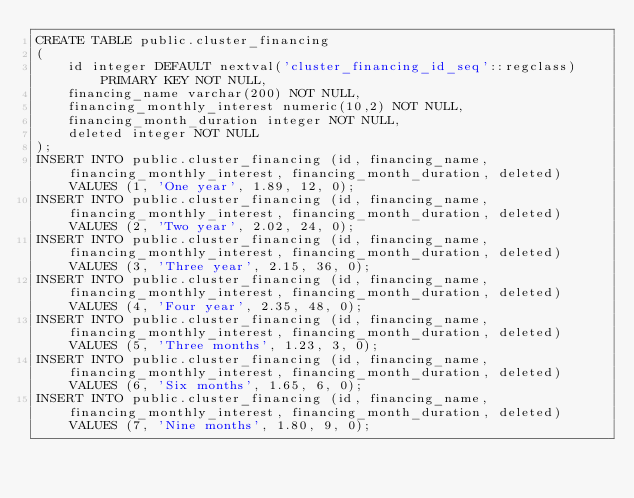<code> <loc_0><loc_0><loc_500><loc_500><_SQL_>CREATE TABLE public.cluster_financing
(
    id integer DEFAULT nextval('cluster_financing_id_seq'::regclass) PRIMARY KEY NOT NULL,
    financing_name varchar(200) NOT NULL,
    financing_monthly_interest numeric(10,2) NOT NULL,
    financing_month_duration integer NOT NULL,
    deleted integer NOT NULL
);
INSERT INTO public.cluster_financing (id, financing_name, financing_monthly_interest, financing_month_duration, deleted) VALUES (1, 'One year', 1.89, 12, 0);
INSERT INTO public.cluster_financing (id, financing_name, financing_monthly_interest, financing_month_duration, deleted) VALUES (2, 'Two year', 2.02, 24, 0);
INSERT INTO public.cluster_financing (id, financing_name, financing_monthly_interest, financing_month_duration, deleted) VALUES (3, 'Three year', 2.15, 36, 0);
INSERT INTO public.cluster_financing (id, financing_name, financing_monthly_interest, financing_month_duration, deleted) VALUES (4, 'Four year', 2.35, 48, 0);
INSERT INTO public.cluster_financing (id, financing_name, financing_monthly_interest, financing_month_duration, deleted) VALUES (5, 'Three months', 1.23, 3, 0);
INSERT INTO public.cluster_financing (id, financing_name, financing_monthly_interest, financing_month_duration, deleted) VALUES (6, 'Six months', 1.65, 6, 0);
INSERT INTO public.cluster_financing (id, financing_name, financing_monthly_interest, financing_month_duration, deleted) VALUES (7, 'Nine months', 1.80, 9, 0);</code> 